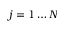Convert formula to latex. <formula><loc_0><loc_0><loc_500><loc_500>j = 1 \dots N</formula> 